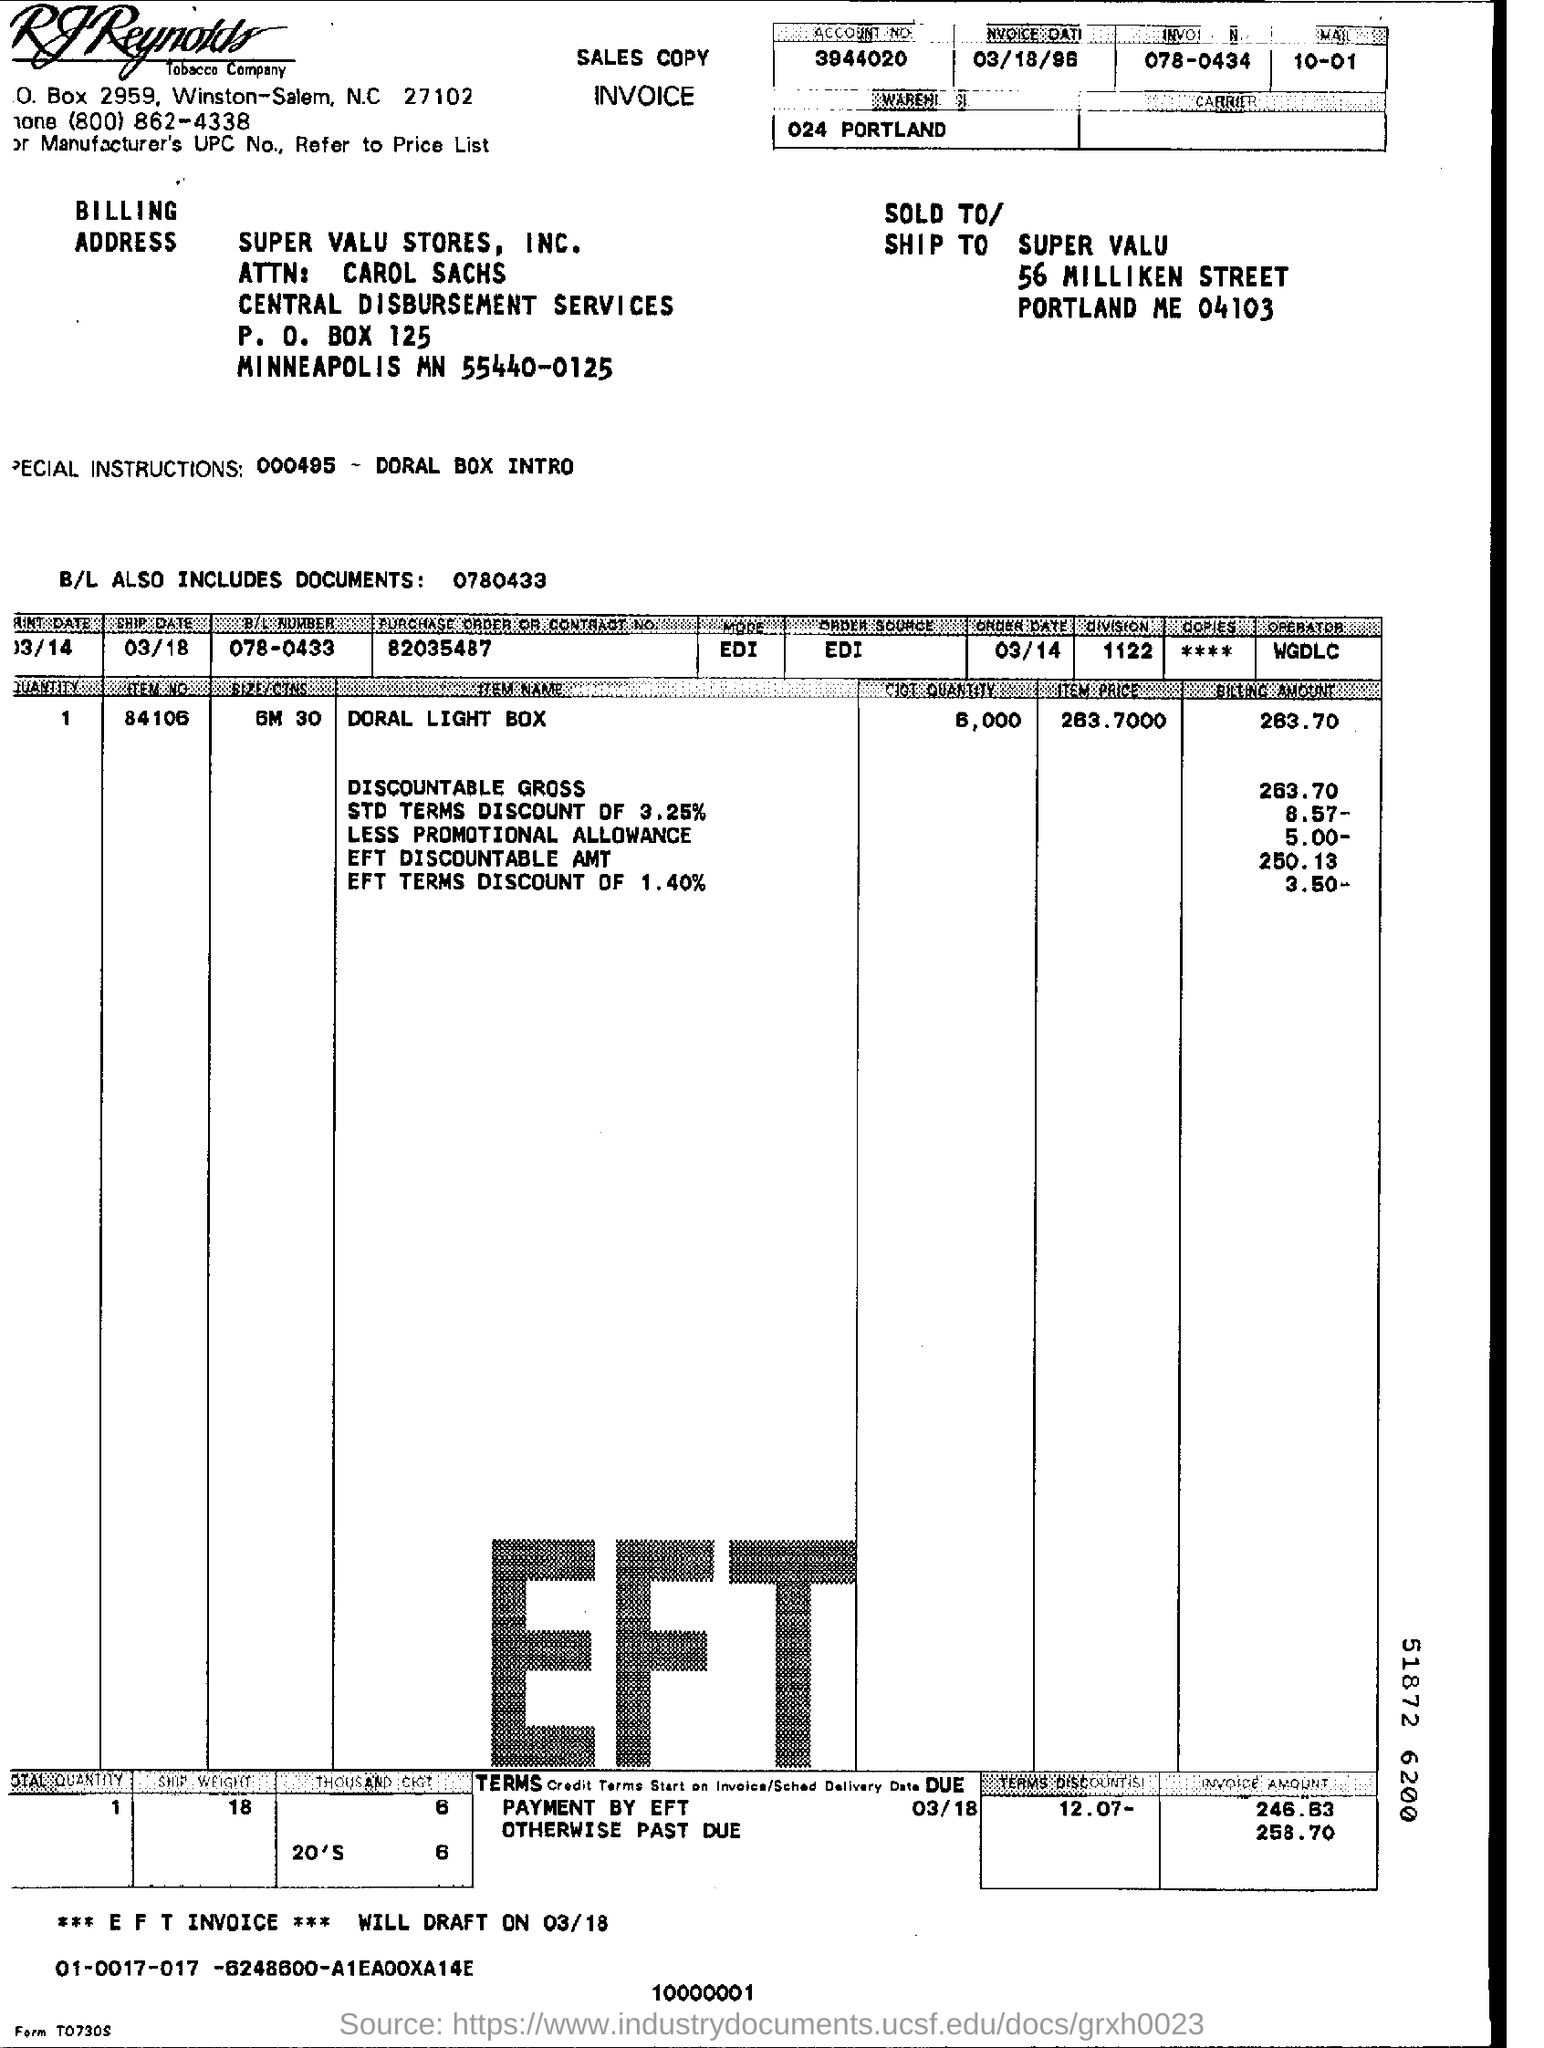Mention a couple of crucial points in this snapshot. The operator is WGDLC. The order date is March 14th. The B/L number 078-0433 is... The division is 1122...," which means that the result of the division of two numbers is 1122. The purchase order or contract number is 82035487... 